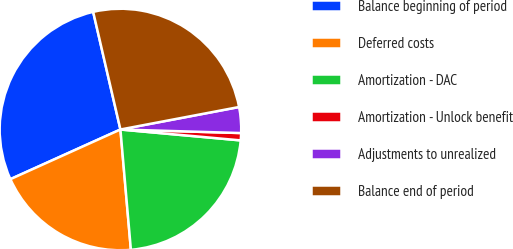Convert chart. <chart><loc_0><loc_0><loc_500><loc_500><pie_chart><fcel>Balance beginning of period<fcel>Deferred costs<fcel>Amortization - DAC<fcel>Amortization - Unlock benefit<fcel>Adjustments to unrealized<fcel>Balance end of period<nl><fcel>28.12%<fcel>19.63%<fcel>22.18%<fcel>0.97%<fcel>3.45%<fcel>25.64%<nl></chart> 